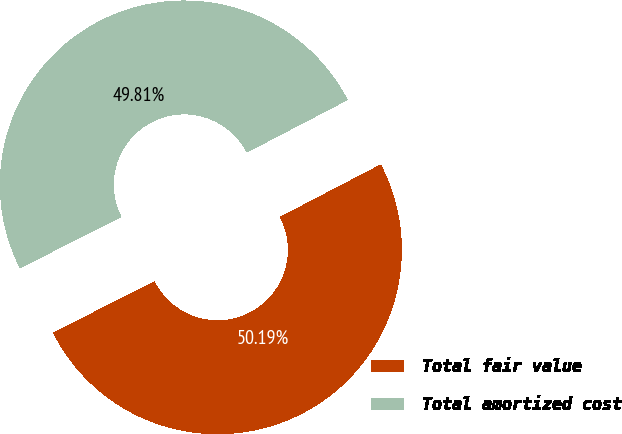<chart> <loc_0><loc_0><loc_500><loc_500><pie_chart><fcel>Total fair value<fcel>Total amortized cost<nl><fcel>50.19%<fcel>49.81%<nl></chart> 